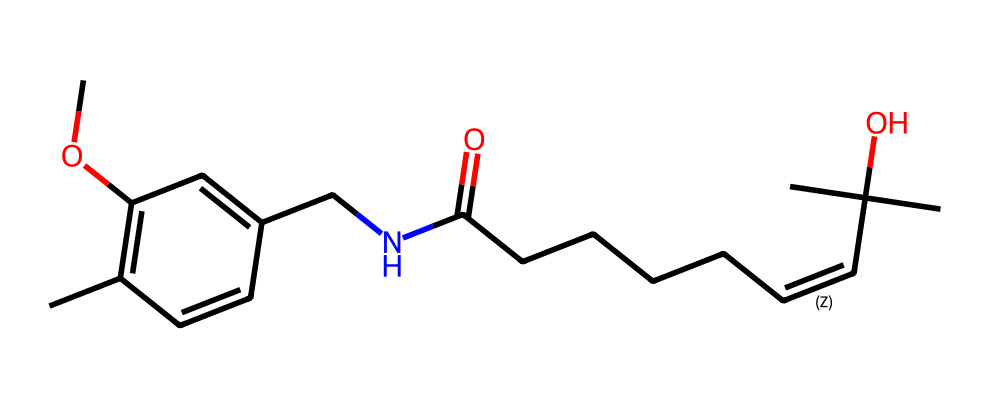What is the total number of carbon atoms in this chemical structure? Counting the carbon atoms in the SMILES representation reveals that there are 22 carbon atoms displayed.
Answer: 22 What type of functional group is present in this chemical? The presence of the -C(=O)NH- sequence indicates the presence of an amide functional group in the structure.
Answer: amide How many double bonds are present in this structure? By analyzing the structure, it is evident that there are 3 double bonds present, indicated by the '=' symbols in the SMILES notation.
Answer: 3 What type of compound is represented by this chemical structure? This chemical belongs to the class of alkaloids due to the presence of nitrogen atoms and its bioactive characteristics.
Answer: alkaloid Which element is immediately adjacent to the carbon that has a hydroxyl (-OH) group? In the SMILES notation, the hydroxyl group appears associated with a carbon atom adjacent to a tertiary carbon (denoted by C(C)(C)).
Answer: tertiary carbon 